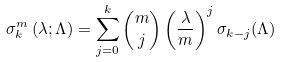Convert formula to latex. <formula><loc_0><loc_0><loc_500><loc_500>\sigma _ { k } ^ { m } \left ( \lambda ; \Lambda \right ) = \sum _ { j = 0 } ^ { k } \binom { m } { j } \left ( \frac { \lambda } { m } \right ) ^ { j } \sigma _ { k - j } ( \Lambda )</formula> 